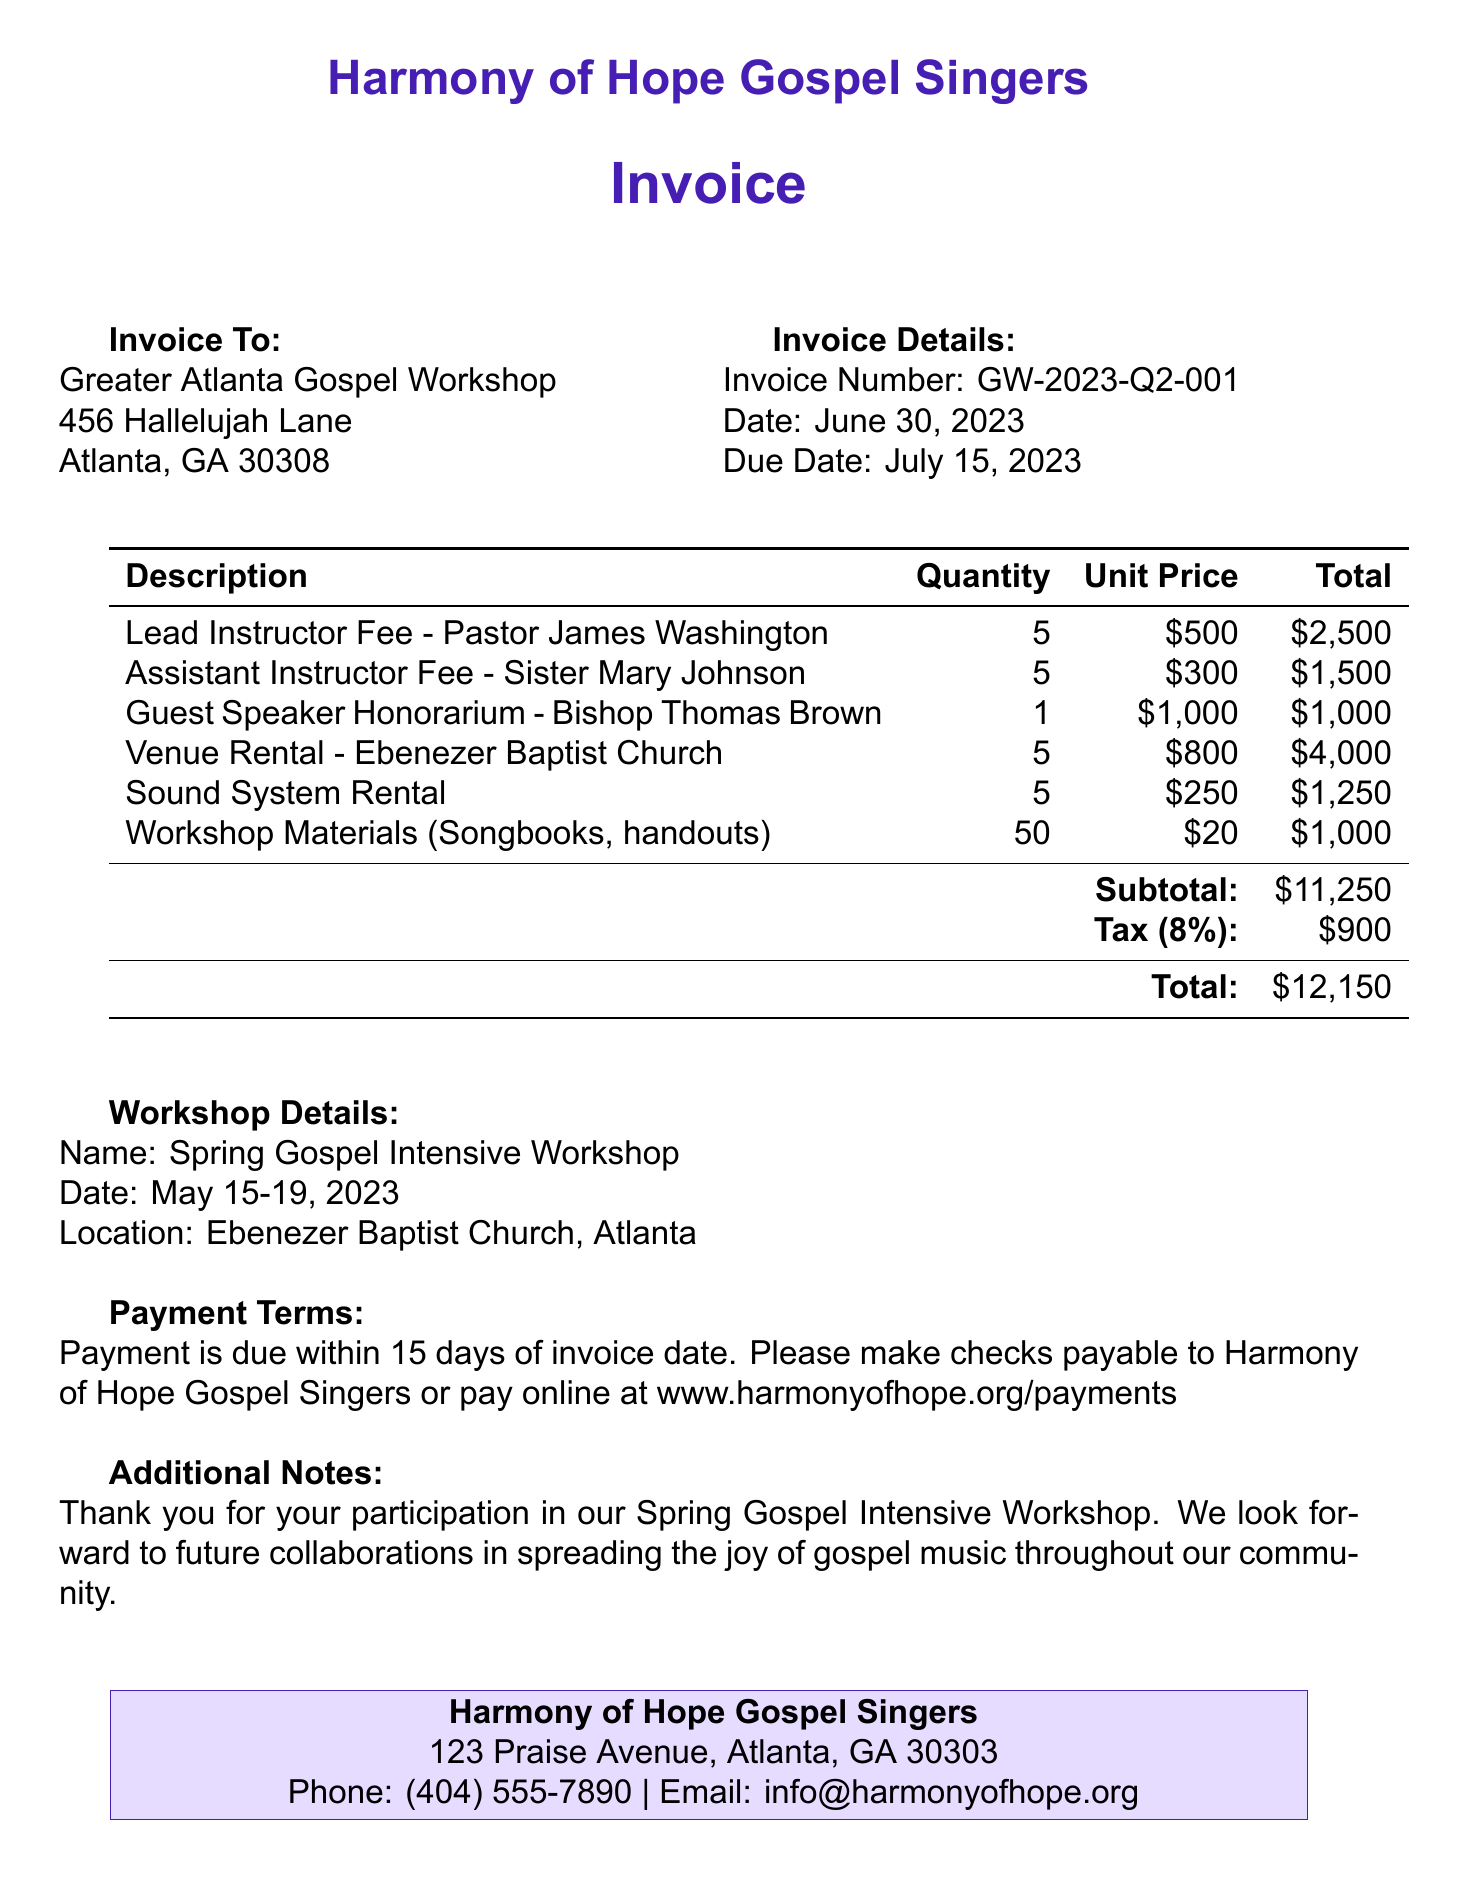What is the invoice number? The invoice number is located in the invoice details section, which is indicated as GW-2023-Q2-001.
Answer: GW-2023-Q2-001 What is the total amount due? The total amount due is presented at the end of the line item calculations, stated as $12,150.
Answer: $12,150 Who is the lead instructor? The lead instructor's name is mentioned in the line items, specifically as Pastor James Washington.
Answer: Pastor James Washington What is the due date for the invoice? The due date is listed in the invoice details section, specified as July 15, 2023.
Answer: July 15, 2023 How many participants received workshop materials? The quantity of workshop materials is found in the line items, which indicates 50 songbooks and handouts were provided.
Answer: 50 What is the tax rate applied to the invoice? The tax rate is mentioned in the calculations of the invoice as 8%.
Answer: 8% What venue was used for the workshop? The venue used for the workshop is explicitly noted in the workshop details section as Ebenezer Baptist Church.
Answer: Ebenezer Baptist Church What is the quantity of the assistant instructor fee? The quantity for the assistant instructor fee is stated in the line items as 5.
Answer: 5 What additional notes are provided in the invoice? The additional notes express gratitude and mention future collaborations, found at the end of the invoice.
Answer: Thank you for your participation in our Spring Gospel Intensive Workshop. We look forward to future collaborations in spreading the joy of gospel music throughout our community 